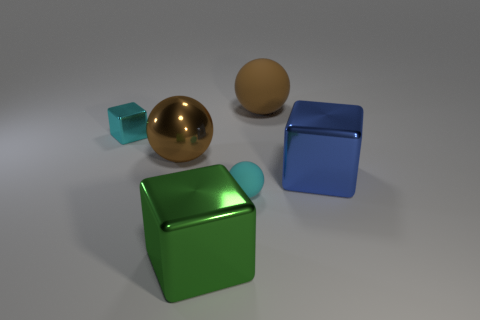There is a metal object that is to the left of the large metal thing behind the blue block; what number of brown objects are in front of it? 1 